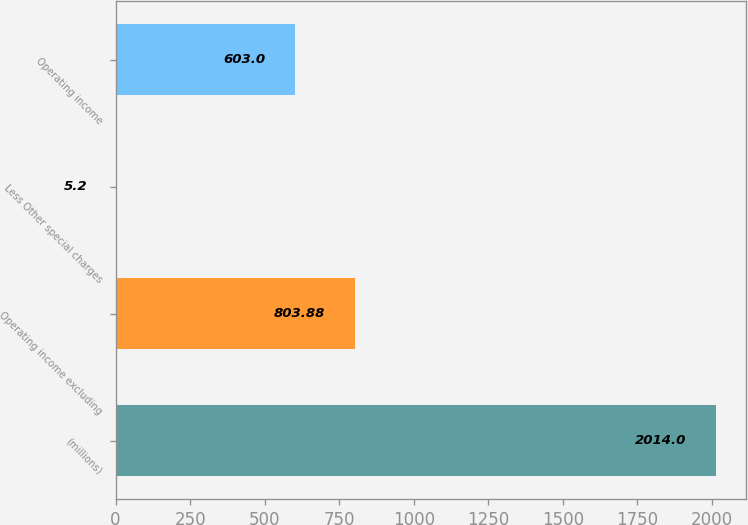Convert chart to OTSL. <chart><loc_0><loc_0><loc_500><loc_500><bar_chart><fcel>(millions)<fcel>Operating income excluding<fcel>Less Other special charges<fcel>Operating income<nl><fcel>2014<fcel>803.88<fcel>5.2<fcel>603<nl></chart> 